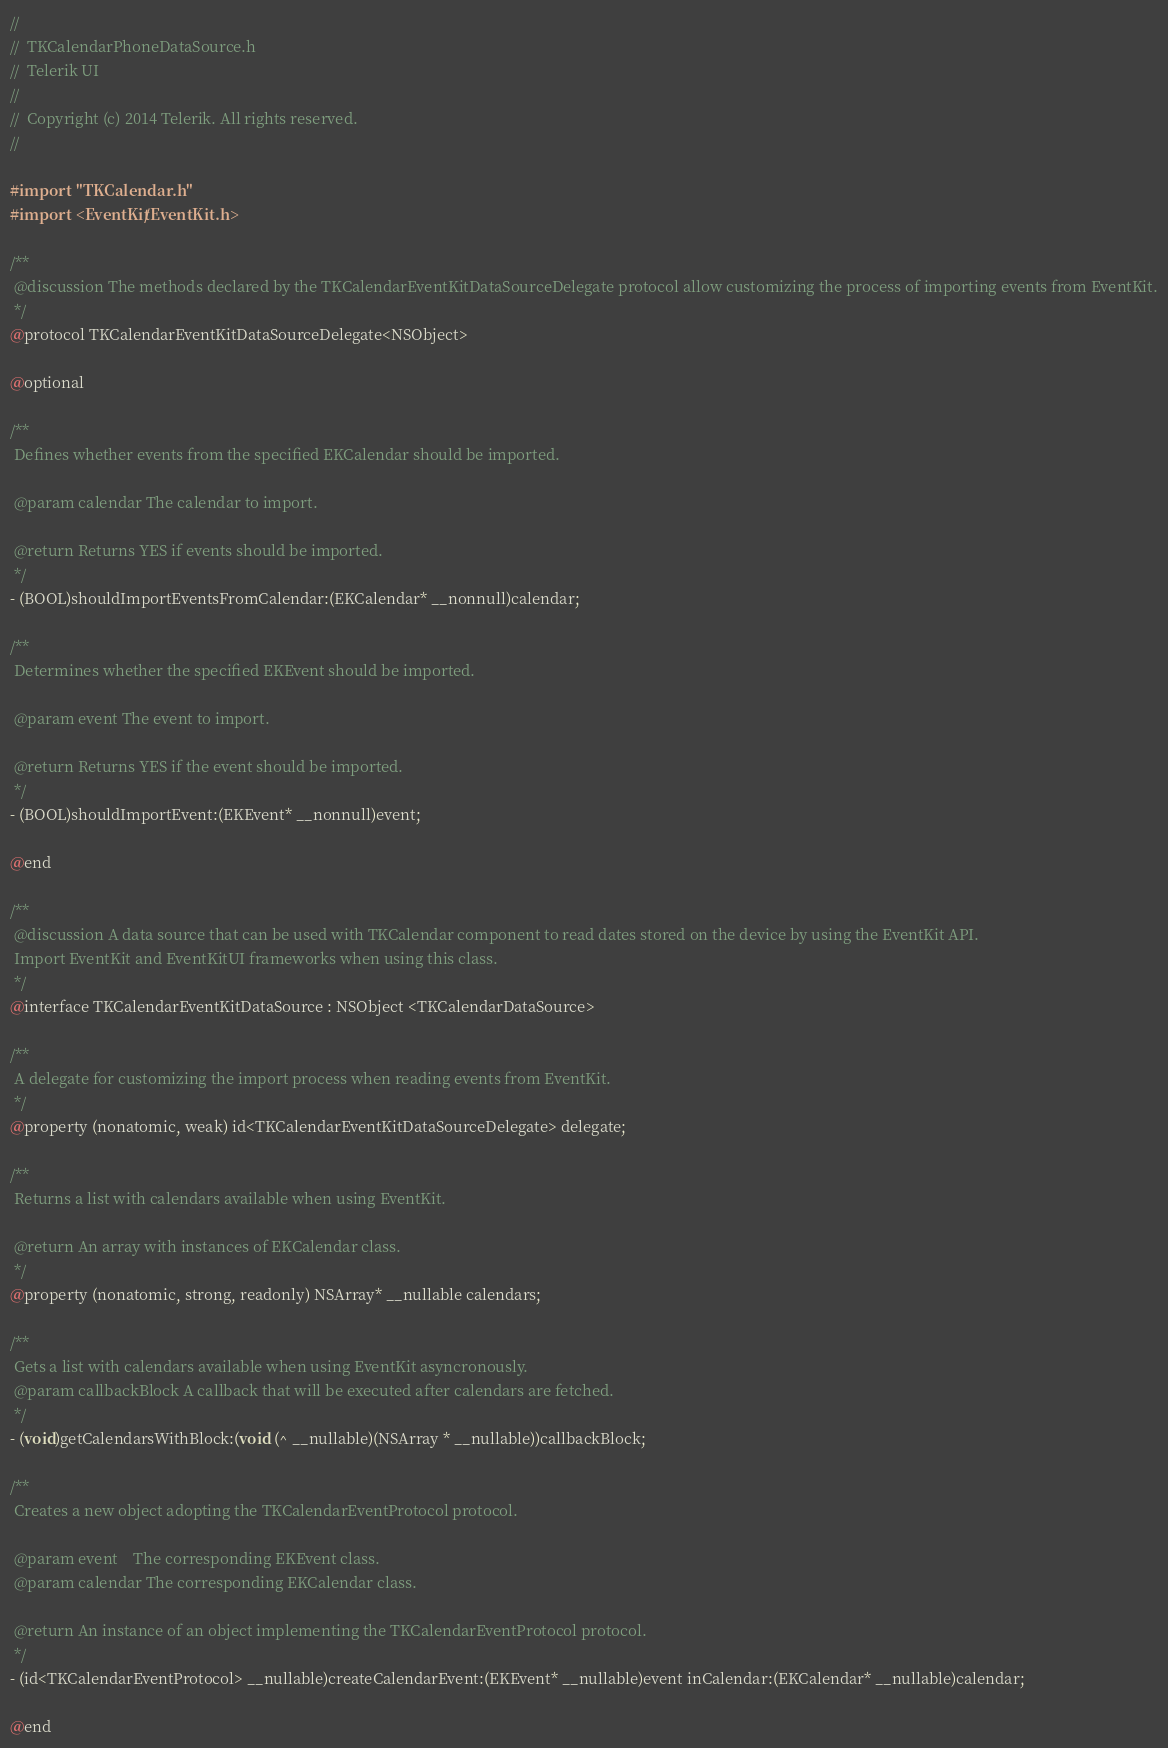<code> <loc_0><loc_0><loc_500><loc_500><_C_>//
//  TKCalendarPhoneDataSource.h
//  Telerik UI
//
//  Copyright (c) 2014 Telerik. All rights reserved.
//

#import "TKCalendar.h"
#import <EventKit/EventKit.h>

/**
 @discussion The methods declared by the TKCalendarEventKitDataSourceDelegate protocol allow customizing the process of importing events from EventKit.
 */
@protocol TKCalendarEventKitDataSourceDelegate<NSObject>

@optional

/**
 Defines whether events from the specified EKCalendar should be imported.
 
 @param calendar The calendar to import.
 
 @return Returns YES if events should be imported.
 */
- (BOOL)shouldImportEventsFromCalendar:(EKCalendar* __nonnull)calendar;

/**
 Determines whether the specified EKEvent should be imported.
 
 @param event The event to import.
 
 @return Returns YES if the event should be imported.
 */
- (BOOL)shouldImportEvent:(EKEvent* __nonnull)event;

@end

/**
 @discussion A data source that can be used with TKCalendar component to read dates stored on the device by using the EventKit API.
 Import EventKit and EventKitUI frameworks when using this class.
 */
@interface TKCalendarEventKitDataSource : NSObject <TKCalendarDataSource>

/**
 A delegate for customizing the import process when reading events from EventKit.
 */
@property (nonatomic, weak) id<TKCalendarEventKitDataSourceDelegate> delegate;

/**
 Returns a list with calendars available when using EventKit.

 @return An array with instances of EKCalendar class.
 */
@property (nonatomic, strong, readonly) NSArray* __nullable calendars;

/**
 Gets a list with calendars available when using EventKit asyncronously.
 @param callbackBlock A callback that will be executed after calendars are fetched.
 */
- (void)getCalendarsWithBlock:(void (^ __nullable)(NSArray * __nullable))callbackBlock;

/**
 Creates a new object adopting the TKCalendarEventProtocol protocol.
 
 @param event    The corresponding EKEvent class.
 @param calendar The corresponding EKCalendar class.
 
 @return An instance of an object implementing the TKCalendarEventProtocol protocol.
 */
- (id<TKCalendarEventProtocol> __nullable)createCalendarEvent:(EKEvent* __nullable)event inCalendar:(EKCalendar* __nullable)calendar;

@end
</code> 